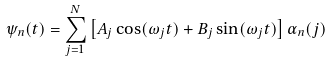<formula> <loc_0><loc_0><loc_500><loc_500>\psi _ { n } ( t ) = \sum _ { j = 1 } ^ { N } \left [ A _ { j } \cos ( \omega _ { j } t ) + B _ { j } \sin ( \omega _ { j } t ) \right ] \alpha _ { n } ( j )</formula> 